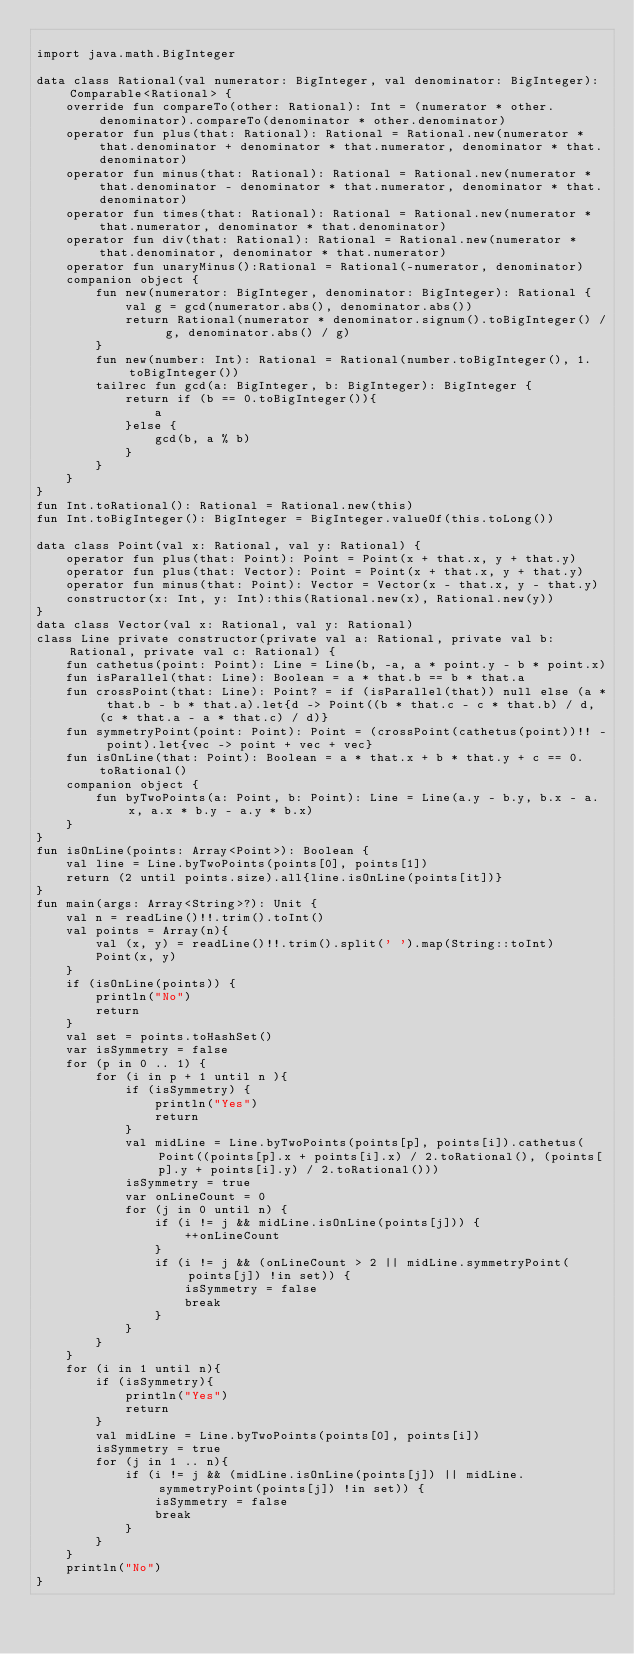<code> <loc_0><loc_0><loc_500><loc_500><_Kotlin_>
import java.math.BigInteger

data class Rational(val numerator: BigInteger, val denominator: BigInteger): Comparable<Rational> {
    override fun compareTo(other: Rational): Int = (numerator * other.denominator).compareTo(denominator * other.denominator)
    operator fun plus(that: Rational): Rational = Rational.new(numerator * that.denominator + denominator * that.numerator, denominator * that.denominator)
    operator fun minus(that: Rational): Rational = Rational.new(numerator * that.denominator - denominator * that.numerator, denominator * that.denominator)
    operator fun times(that: Rational): Rational = Rational.new(numerator * that.numerator, denominator * that.denominator)
    operator fun div(that: Rational): Rational = Rational.new(numerator * that.denominator, denominator * that.numerator)
    operator fun unaryMinus():Rational = Rational(-numerator, denominator)
    companion object {
        fun new(numerator: BigInteger, denominator: BigInteger): Rational {
            val g = gcd(numerator.abs(), denominator.abs())
            return Rational(numerator * denominator.signum().toBigInteger() / g, denominator.abs() / g)
        }
        fun new(number: Int): Rational = Rational(number.toBigInteger(), 1.toBigInteger())
        tailrec fun gcd(a: BigInteger, b: BigInteger): BigInteger {
            return if (b == 0.toBigInteger()){
                a
            }else {
                gcd(b, a % b)
            }
        }
    }
}
fun Int.toRational(): Rational = Rational.new(this)
fun Int.toBigInteger(): BigInteger = BigInteger.valueOf(this.toLong())

data class Point(val x: Rational, val y: Rational) {
    operator fun plus(that: Point): Point = Point(x + that.x, y + that.y)
    operator fun plus(that: Vector): Point = Point(x + that.x, y + that.y)
    operator fun minus(that: Point): Vector = Vector(x - that.x, y - that.y)
    constructor(x: Int, y: Int):this(Rational.new(x), Rational.new(y))
}
data class Vector(val x: Rational, val y: Rational)
class Line private constructor(private val a: Rational, private val b: Rational, private val c: Rational) {
    fun cathetus(point: Point): Line = Line(b, -a, a * point.y - b * point.x)
    fun isParallel(that: Line): Boolean = a * that.b == b * that.a
    fun crossPoint(that: Line): Point? = if (isParallel(that)) null else (a * that.b - b * that.a).let{d -> Point((b * that.c - c * that.b) / d, (c * that.a - a * that.c) / d)}
    fun symmetryPoint(point: Point): Point = (crossPoint(cathetus(point))!! - point).let{vec -> point + vec + vec}
    fun isOnLine(that: Point): Boolean = a * that.x + b * that.y + c == 0.toRational()
    companion object {
        fun byTwoPoints(a: Point, b: Point): Line = Line(a.y - b.y, b.x - a. x, a.x * b.y - a.y * b.x)
    }
}
fun isOnLine(points: Array<Point>): Boolean {
    val line = Line.byTwoPoints(points[0], points[1])
    return (2 until points.size).all{line.isOnLine(points[it])}
}
fun main(args: Array<String>?): Unit {
    val n = readLine()!!.trim().toInt()
    val points = Array(n){
        val (x, y) = readLine()!!.trim().split(' ').map(String::toInt)
        Point(x, y)
    }
    if (isOnLine(points)) {
        println("No")
        return
    }
    val set = points.toHashSet()
    var isSymmetry = false
    for (p in 0 .. 1) {
        for (i in p + 1 until n ){
            if (isSymmetry) {
                println("Yes")
                return
            }
            val midLine = Line.byTwoPoints(points[p], points[i]).cathetus(Point((points[p].x + points[i].x) / 2.toRational(), (points[p].y + points[i].y) / 2.toRational()))
            isSymmetry = true
            var onLineCount = 0
            for (j in 0 until n) {
                if (i != j && midLine.isOnLine(points[j])) {
                    ++onLineCount
                }
                if (i != j && (onLineCount > 2 || midLine.symmetryPoint(points[j]) !in set)) {
                    isSymmetry = false
                    break
                }
            }
        }
    }
    for (i in 1 until n){
        if (isSymmetry){
            println("Yes")
            return
        }
        val midLine = Line.byTwoPoints(points[0], points[i])
        isSymmetry = true
        for (j in 1 .. n){
            if (i != j && (midLine.isOnLine(points[j]) || midLine.symmetryPoint(points[j]) !in set)) {
                isSymmetry = false
                break
            }
        }
    }
    println("No")
}
</code> 